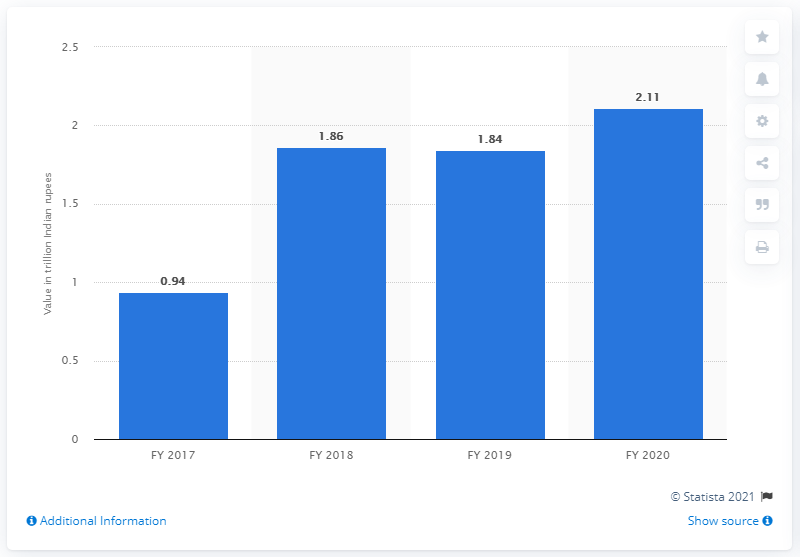Identify some key points in this picture. The value of gross non-performing assets of private banks in India in the fiscal year 2020 was 2.11 trillion. The gross non-performing assets (NPA) in Indian rupees is 2.11... 